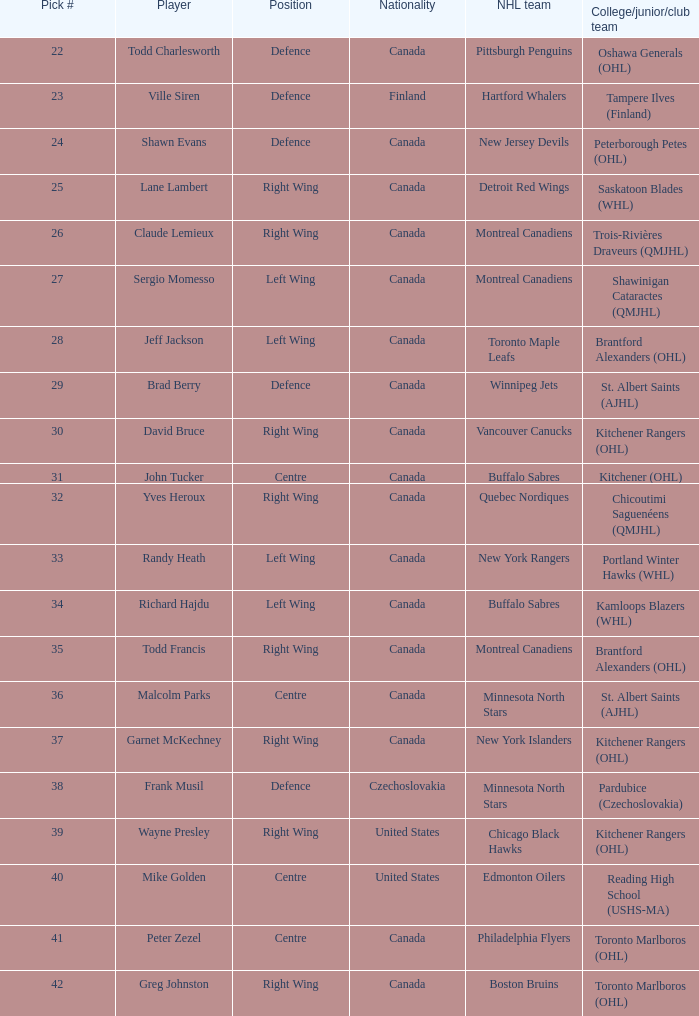What is the pick # when the nhl team is montreal canadiens and the college/junior/club team is trois-rivières draveurs (qmjhl)? 26.0. 